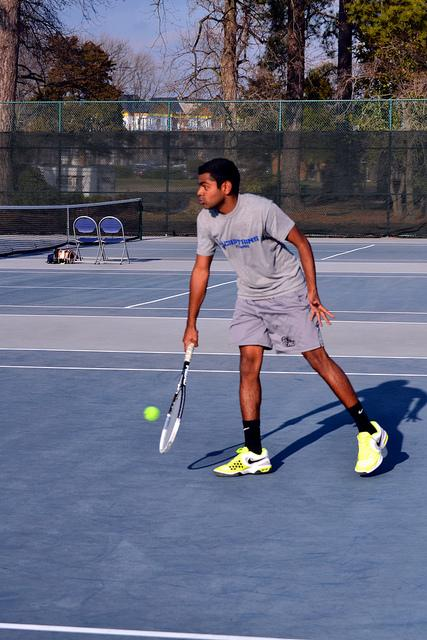Which object is in motion?

Choices:
A) fence
B) chair
C) net
D) ball ball 